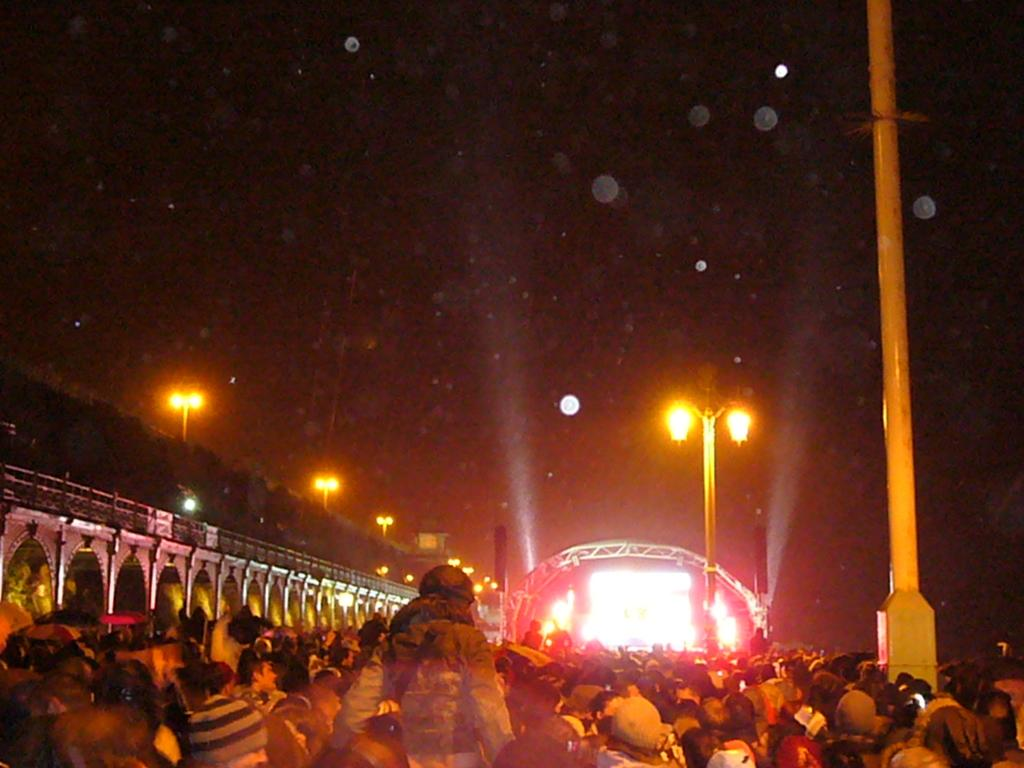What can be seen in the image involving human subjects? There are people standing in the image. What is located on the left side of the image? There is a wall on the left side of the image. What can be seen in the background of the image? There is lighting and poles in the background of the image. What type of donkey can be seen walking under the arch in the image? There is no donkey or arch present in the image. How quiet is the environment in the image? The image does not provide any information about the noise level or the environment's quietness. 